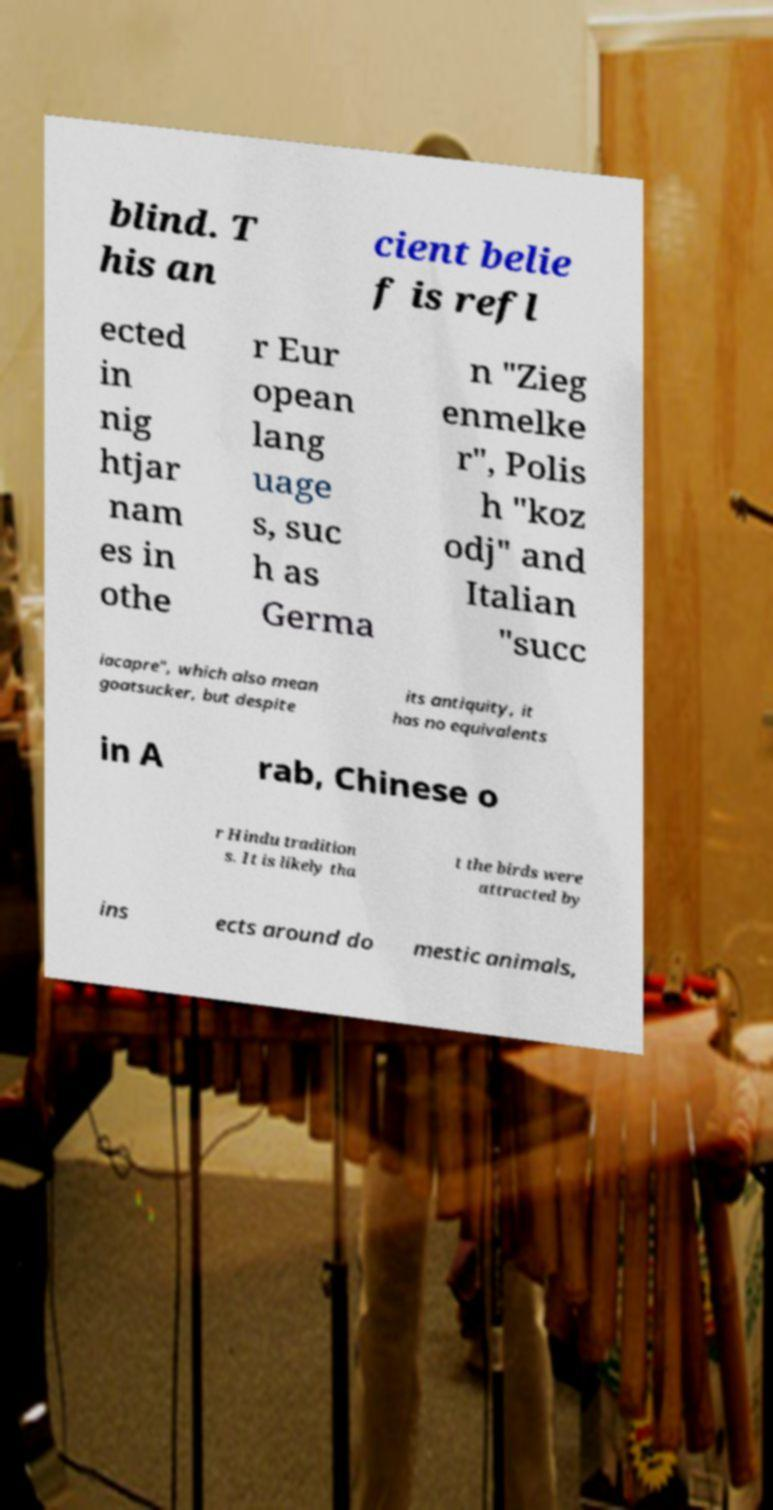Please identify and transcribe the text found in this image. blind. T his an cient belie f is refl ected in nig htjar nam es in othe r Eur opean lang uage s, suc h as Germa n "Zieg enmelke r", Polis h "koz odj" and Italian "succ iacapre", which also mean goatsucker, but despite its antiquity, it has no equivalents in A rab, Chinese o r Hindu tradition s. It is likely tha t the birds were attracted by ins ects around do mestic animals, 